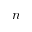Convert formula to latex. <formula><loc_0><loc_0><loc_500><loc_500>n</formula> 